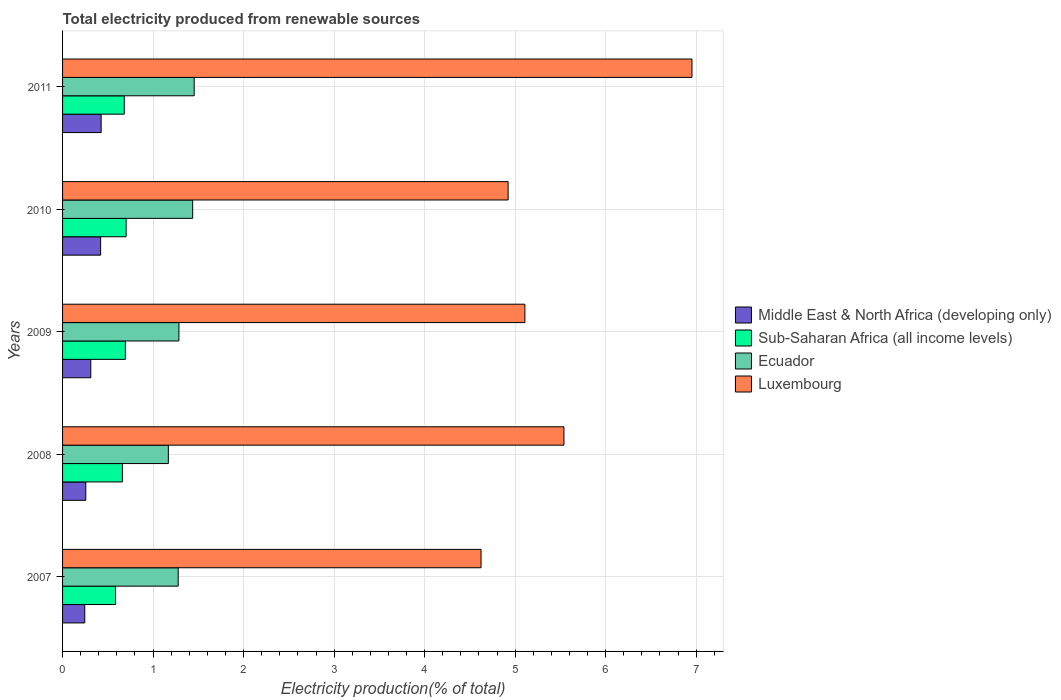How many different coloured bars are there?
Provide a succinct answer. 4. How many groups of bars are there?
Your answer should be compact. 5. Are the number of bars per tick equal to the number of legend labels?
Keep it short and to the point. Yes. How many bars are there on the 3rd tick from the top?
Your answer should be very brief. 4. What is the label of the 4th group of bars from the top?
Ensure brevity in your answer.  2008. What is the total electricity produced in Ecuador in 2009?
Make the answer very short. 1.29. Across all years, what is the maximum total electricity produced in Middle East & North Africa (developing only)?
Offer a terse response. 0.43. Across all years, what is the minimum total electricity produced in Sub-Saharan Africa (all income levels)?
Make the answer very short. 0.58. What is the total total electricity produced in Sub-Saharan Africa (all income levels) in the graph?
Offer a terse response. 3.32. What is the difference between the total electricity produced in Sub-Saharan Africa (all income levels) in 2008 and that in 2011?
Your response must be concise. -0.02. What is the difference between the total electricity produced in Luxembourg in 2011 and the total electricity produced in Sub-Saharan Africa (all income levels) in 2007?
Your answer should be very brief. 6.37. What is the average total electricity produced in Sub-Saharan Africa (all income levels) per year?
Provide a succinct answer. 0.66. In the year 2010, what is the difference between the total electricity produced in Ecuador and total electricity produced in Luxembourg?
Ensure brevity in your answer.  -3.49. In how many years, is the total electricity produced in Ecuador greater than 1.8 %?
Your response must be concise. 0. What is the ratio of the total electricity produced in Sub-Saharan Africa (all income levels) in 2009 to that in 2011?
Provide a succinct answer. 1.02. Is the total electricity produced in Luxembourg in 2010 less than that in 2011?
Keep it short and to the point. Yes. What is the difference between the highest and the second highest total electricity produced in Sub-Saharan Africa (all income levels)?
Provide a short and direct response. 0.01. What is the difference between the highest and the lowest total electricity produced in Sub-Saharan Africa (all income levels)?
Give a very brief answer. 0.12. In how many years, is the total electricity produced in Ecuador greater than the average total electricity produced in Ecuador taken over all years?
Ensure brevity in your answer.  2. Is the sum of the total electricity produced in Sub-Saharan Africa (all income levels) in 2008 and 2011 greater than the maximum total electricity produced in Ecuador across all years?
Your answer should be compact. No. What does the 1st bar from the top in 2010 represents?
Provide a short and direct response. Luxembourg. What does the 3rd bar from the bottom in 2010 represents?
Keep it short and to the point. Ecuador. How many years are there in the graph?
Keep it short and to the point. 5. Does the graph contain any zero values?
Give a very brief answer. No. Does the graph contain grids?
Give a very brief answer. Yes. Where does the legend appear in the graph?
Provide a short and direct response. Center right. How many legend labels are there?
Your response must be concise. 4. What is the title of the graph?
Your answer should be compact. Total electricity produced from renewable sources. What is the label or title of the X-axis?
Your answer should be compact. Electricity production(% of total). What is the Electricity production(% of total) in Middle East & North Africa (developing only) in 2007?
Offer a terse response. 0.25. What is the Electricity production(% of total) in Sub-Saharan Africa (all income levels) in 2007?
Make the answer very short. 0.58. What is the Electricity production(% of total) of Ecuador in 2007?
Your answer should be compact. 1.28. What is the Electricity production(% of total) of Luxembourg in 2007?
Provide a short and direct response. 4.62. What is the Electricity production(% of total) in Middle East & North Africa (developing only) in 2008?
Your answer should be compact. 0.26. What is the Electricity production(% of total) in Sub-Saharan Africa (all income levels) in 2008?
Make the answer very short. 0.66. What is the Electricity production(% of total) in Ecuador in 2008?
Ensure brevity in your answer.  1.17. What is the Electricity production(% of total) in Luxembourg in 2008?
Your answer should be very brief. 5.54. What is the Electricity production(% of total) in Middle East & North Africa (developing only) in 2009?
Ensure brevity in your answer.  0.31. What is the Electricity production(% of total) of Sub-Saharan Africa (all income levels) in 2009?
Make the answer very short. 0.69. What is the Electricity production(% of total) of Ecuador in 2009?
Your answer should be very brief. 1.29. What is the Electricity production(% of total) in Luxembourg in 2009?
Give a very brief answer. 5.11. What is the Electricity production(% of total) of Middle East & North Africa (developing only) in 2010?
Provide a succinct answer. 0.42. What is the Electricity production(% of total) of Sub-Saharan Africa (all income levels) in 2010?
Give a very brief answer. 0.7. What is the Electricity production(% of total) in Ecuador in 2010?
Give a very brief answer. 1.44. What is the Electricity production(% of total) in Luxembourg in 2010?
Provide a succinct answer. 4.92. What is the Electricity production(% of total) of Middle East & North Africa (developing only) in 2011?
Offer a terse response. 0.43. What is the Electricity production(% of total) of Sub-Saharan Africa (all income levels) in 2011?
Give a very brief answer. 0.68. What is the Electricity production(% of total) of Ecuador in 2011?
Make the answer very short. 1.45. What is the Electricity production(% of total) of Luxembourg in 2011?
Your response must be concise. 6.95. Across all years, what is the maximum Electricity production(% of total) of Middle East & North Africa (developing only)?
Your answer should be compact. 0.43. Across all years, what is the maximum Electricity production(% of total) of Sub-Saharan Africa (all income levels)?
Give a very brief answer. 0.7. Across all years, what is the maximum Electricity production(% of total) in Ecuador?
Your answer should be compact. 1.45. Across all years, what is the maximum Electricity production(% of total) of Luxembourg?
Ensure brevity in your answer.  6.95. Across all years, what is the minimum Electricity production(% of total) in Middle East & North Africa (developing only)?
Provide a succinct answer. 0.25. Across all years, what is the minimum Electricity production(% of total) in Sub-Saharan Africa (all income levels)?
Provide a succinct answer. 0.58. Across all years, what is the minimum Electricity production(% of total) in Ecuador?
Your response must be concise. 1.17. Across all years, what is the minimum Electricity production(% of total) of Luxembourg?
Give a very brief answer. 4.62. What is the total Electricity production(% of total) of Middle East & North Africa (developing only) in the graph?
Offer a terse response. 1.66. What is the total Electricity production(% of total) of Sub-Saharan Africa (all income levels) in the graph?
Provide a succinct answer. 3.32. What is the total Electricity production(% of total) of Ecuador in the graph?
Make the answer very short. 6.62. What is the total Electricity production(% of total) of Luxembourg in the graph?
Your answer should be very brief. 27.15. What is the difference between the Electricity production(% of total) in Middle East & North Africa (developing only) in 2007 and that in 2008?
Your answer should be compact. -0.01. What is the difference between the Electricity production(% of total) in Sub-Saharan Africa (all income levels) in 2007 and that in 2008?
Give a very brief answer. -0.08. What is the difference between the Electricity production(% of total) of Ecuador in 2007 and that in 2008?
Your response must be concise. 0.11. What is the difference between the Electricity production(% of total) in Luxembourg in 2007 and that in 2008?
Provide a short and direct response. -0.92. What is the difference between the Electricity production(% of total) in Middle East & North Africa (developing only) in 2007 and that in 2009?
Make the answer very short. -0.07. What is the difference between the Electricity production(% of total) in Sub-Saharan Africa (all income levels) in 2007 and that in 2009?
Offer a very short reply. -0.11. What is the difference between the Electricity production(% of total) in Ecuador in 2007 and that in 2009?
Ensure brevity in your answer.  -0.01. What is the difference between the Electricity production(% of total) in Luxembourg in 2007 and that in 2009?
Give a very brief answer. -0.48. What is the difference between the Electricity production(% of total) in Middle East & North Africa (developing only) in 2007 and that in 2010?
Provide a short and direct response. -0.18. What is the difference between the Electricity production(% of total) of Sub-Saharan Africa (all income levels) in 2007 and that in 2010?
Provide a succinct answer. -0.12. What is the difference between the Electricity production(% of total) of Ecuador in 2007 and that in 2010?
Provide a succinct answer. -0.16. What is the difference between the Electricity production(% of total) in Luxembourg in 2007 and that in 2010?
Your answer should be very brief. -0.3. What is the difference between the Electricity production(% of total) of Middle East & North Africa (developing only) in 2007 and that in 2011?
Give a very brief answer. -0.18. What is the difference between the Electricity production(% of total) in Sub-Saharan Africa (all income levels) in 2007 and that in 2011?
Your answer should be compact. -0.1. What is the difference between the Electricity production(% of total) of Ecuador in 2007 and that in 2011?
Your response must be concise. -0.18. What is the difference between the Electricity production(% of total) in Luxembourg in 2007 and that in 2011?
Your response must be concise. -2.33. What is the difference between the Electricity production(% of total) in Middle East & North Africa (developing only) in 2008 and that in 2009?
Give a very brief answer. -0.06. What is the difference between the Electricity production(% of total) in Sub-Saharan Africa (all income levels) in 2008 and that in 2009?
Keep it short and to the point. -0.03. What is the difference between the Electricity production(% of total) in Ecuador in 2008 and that in 2009?
Your response must be concise. -0.12. What is the difference between the Electricity production(% of total) of Luxembourg in 2008 and that in 2009?
Provide a succinct answer. 0.43. What is the difference between the Electricity production(% of total) in Middle East & North Africa (developing only) in 2008 and that in 2010?
Keep it short and to the point. -0.16. What is the difference between the Electricity production(% of total) of Sub-Saharan Africa (all income levels) in 2008 and that in 2010?
Offer a terse response. -0.04. What is the difference between the Electricity production(% of total) of Ecuador in 2008 and that in 2010?
Provide a succinct answer. -0.27. What is the difference between the Electricity production(% of total) in Luxembourg in 2008 and that in 2010?
Offer a terse response. 0.62. What is the difference between the Electricity production(% of total) of Middle East & North Africa (developing only) in 2008 and that in 2011?
Your answer should be compact. -0.17. What is the difference between the Electricity production(% of total) of Sub-Saharan Africa (all income levels) in 2008 and that in 2011?
Make the answer very short. -0.02. What is the difference between the Electricity production(% of total) of Ecuador in 2008 and that in 2011?
Keep it short and to the point. -0.29. What is the difference between the Electricity production(% of total) of Luxembourg in 2008 and that in 2011?
Your response must be concise. -1.41. What is the difference between the Electricity production(% of total) of Middle East & North Africa (developing only) in 2009 and that in 2010?
Keep it short and to the point. -0.11. What is the difference between the Electricity production(% of total) in Sub-Saharan Africa (all income levels) in 2009 and that in 2010?
Keep it short and to the point. -0.01. What is the difference between the Electricity production(% of total) of Ecuador in 2009 and that in 2010?
Provide a succinct answer. -0.15. What is the difference between the Electricity production(% of total) of Luxembourg in 2009 and that in 2010?
Ensure brevity in your answer.  0.19. What is the difference between the Electricity production(% of total) of Middle East & North Africa (developing only) in 2009 and that in 2011?
Offer a terse response. -0.11. What is the difference between the Electricity production(% of total) in Sub-Saharan Africa (all income levels) in 2009 and that in 2011?
Your answer should be compact. 0.01. What is the difference between the Electricity production(% of total) in Ecuador in 2009 and that in 2011?
Provide a succinct answer. -0.17. What is the difference between the Electricity production(% of total) of Luxembourg in 2009 and that in 2011?
Provide a succinct answer. -1.85. What is the difference between the Electricity production(% of total) of Middle East & North Africa (developing only) in 2010 and that in 2011?
Your response must be concise. -0.01. What is the difference between the Electricity production(% of total) in Sub-Saharan Africa (all income levels) in 2010 and that in 2011?
Offer a very short reply. 0.02. What is the difference between the Electricity production(% of total) in Ecuador in 2010 and that in 2011?
Keep it short and to the point. -0.02. What is the difference between the Electricity production(% of total) of Luxembourg in 2010 and that in 2011?
Keep it short and to the point. -2.03. What is the difference between the Electricity production(% of total) of Middle East & North Africa (developing only) in 2007 and the Electricity production(% of total) of Sub-Saharan Africa (all income levels) in 2008?
Your answer should be very brief. -0.42. What is the difference between the Electricity production(% of total) in Middle East & North Africa (developing only) in 2007 and the Electricity production(% of total) in Ecuador in 2008?
Make the answer very short. -0.92. What is the difference between the Electricity production(% of total) of Middle East & North Africa (developing only) in 2007 and the Electricity production(% of total) of Luxembourg in 2008?
Offer a very short reply. -5.29. What is the difference between the Electricity production(% of total) in Sub-Saharan Africa (all income levels) in 2007 and the Electricity production(% of total) in Ecuador in 2008?
Give a very brief answer. -0.58. What is the difference between the Electricity production(% of total) of Sub-Saharan Africa (all income levels) in 2007 and the Electricity production(% of total) of Luxembourg in 2008?
Give a very brief answer. -4.95. What is the difference between the Electricity production(% of total) in Ecuador in 2007 and the Electricity production(% of total) in Luxembourg in 2008?
Your answer should be very brief. -4.26. What is the difference between the Electricity production(% of total) in Middle East & North Africa (developing only) in 2007 and the Electricity production(% of total) in Sub-Saharan Africa (all income levels) in 2009?
Give a very brief answer. -0.45. What is the difference between the Electricity production(% of total) in Middle East & North Africa (developing only) in 2007 and the Electricity production(% of total) in Ecuador in 2009?
Provide a short and direct response. -1.04. What is the difference between the Electricity production(% of total) of Middle East & North Africa (developing only) in 2007 and the Electricity production(% of total) of Luxembourg in 2009?
Your answer should be compact. -4.86. What is the difference between the Electricity production(% of total) of Sub-Saharan Africa (all income levels) in 2007 and the Electricity production(% of total) of Ecuador in 2009?
Your answer should be compact. -0.7. What is the difference between the Electricity production(% of total) in Sub-Saharan Africa (all income levels) in 2007 and the Electricity production(% of total) in Luxembourg in 2009?
Your answer should be very brief. -4.52. What is the difference between the Electricity production(% of total) in Ecuador in 2007 and the Electricity production(% of total) in Luxembourg in 2009?
Your response must be concise. -3.83. What is the difference between the Electricity production(% of total) of Middle East & North Africa (developing only) in 2007 and the Electricity production(% of total) of Sub-Saharan Africa (all income levels) in 2010?
Ensure brevity in your answer.  -0.46. What is the difference between the Electricity production(% of total) of Middle East & North Africa (developing only) in 2007 and the Electricity production(% of total) of Ecuador in 2010?
Ensure brevity in your answer.  -1.19. What is the difference between the Electricity production(% of total) of Middle East & North Africa (developing only) in 2007 and the Electricity production(% of total) of Luxembourg in 2010?
Keep it short and to the point. -4.68. What is the difference between the Electricity production(% of total) of Sub-Saharan Africa (all income levels) in 2007 and the Electricity production(% of total) of Ecuador in 2010?
Offer a terse response. -0.85. What is the difference between the Electricity production(% of total) in Sub-Saharan Africa (all income levels) in 2007 and the Electricity production(% of total) in Luxembourg in 2010?
Keep it short and to the point. -4.34. What is the difference between the Electricity production(% of total) in Ecuador in 2007 and the Electricity production(% of total) in Luxembourg in 2010?
Keep it short and to the point. -3.65. What is the difference between the Electricity production(% of total) in Middle East & North Africa (developing only) in 2007 and the Electricity production(% of total) in Sub-Saharan Africa (all income levels) in 2011?
Your answer should be compact. -0.44. What is the difference between the Electricity production(% of total) in Middle East & North Africa (developing only) in 2007 and the Electricity production(% of total) in Ecuador in 2011?
Provide a short and direct response. -1.21. What is the difference between the Electricity production(% of total) in Middle East & North Africa (developing only) in 2007 and the Electricity production(% of total) in Luxembourg in 2011?
Keep it short and to the point. -6.71. What is the difference between the Electricity production(% of total) of Sub-Saharan Africa (all income levels) in 2007 and the Electricity production(% of total) of Ecuador in 2011?
Keep it short and to the point. -0.87. What is the difference between the Electricity production(% of total) in Sub-Saharan Africa (all income levels) in 2007 and the Electricity production(% of total) in Luxembourg in 2011?
Your response must be concise. -6.37. What is the difference between the Electricity production(% of total) of Ecuador in 2007 and the Electricity production(% of total) of Luxembourg in 2011?
Make the answer very short. -5.68. What is the difference between the Electricity production(% of total) of Middle East & North Africa (developing only) in 2008 and the Electricity production(% of total) of Sub-Saharan Africa (all income levels) in 2009?
Your answer should be compact. -0.44. What is the difference between the Electricity production(% of total) of Middle East & North Africa (developing only) in 2008 and the Electricity production(% of total) of Ecuador in 2009?
Ensure brevity in your answer.  -1.03. What is the difference between the Electricity production(% of total) of Middle East & North Africa (developing only) in 2008 and the Electricity production(% of total) of Luxembourg in 2009?
Keep it short and to the point. -4.85. What is the difference between the Electricity production(% of total) of Sub-Saharan Africa (all income levels) in 2008 and the Electricity production(% of total) of Ecuador in 2009?
Keep it short and to the point. -0.62. What is the difference between the Electricity production(% of total) of Sub-Saharan Africa (all income levels) in 2008 and the Electricity production(% of total) of Luxembourg in 2009?
Offer a terse response. -4.45. What is the difference between the Electricity production(% of total) in Ecuador in 2008 and the Electricity production(% of total) in Luxembourg in 2009?
Your response must be concise. -3.94. What is the difference between the Electricity production(% of total) of Middle East & North Africa (developing only) in 2008 and the Electricity production(% of total) of Sub-Saharan Africa (all income levels) in 2010?
Your answer should be very brief. -0.45. What is the difference between the Electricity production(% of total) in Middle East & North Africa (developing only) in 2008 and the Electricity production(% of total) in Ecuador in 2010?
Provide a succinct answer. -1.18. What is the difference between the Electricity production(% of total) of Middle East & North Africa (developing only) in 2008 and the Electricity production(% of total) of Luxembourg in 2010?
Keep it short and to the point. -4.67. What is the difference between the Electricity production(% of total) of Sub-Saharan Africa (all income levels) in 2008 and the Electricity production(% of total) of Ecuador in 2010?
Provide a short and direct response. -0.78. What is the difference between the Electricity production(% of total) in Sub-Saharan Africa (all income levels) in 2008 and the Electricity production(% of total) in Luxembourg in 2010?
Give a very brief answer. -4.26. What is the difference between the Electricity production(% of total) in Ecuador in 2008 and the Electricity production(% of total) in Luxembourg in 2010?
Provide a short and direct response. -3.75. What is the difference between the Electricity production(% of total) of Middle East & North Africa (developing only) in 2008 and the Electricity production(% of total) of Sub-Saharan Africa (all income levels) in 2011?
Ensure brevity in your answer.  -0.43. What is the difference between the Electricity production(% of total) in Middle East & North Africa (developing only) in 2008 and the Electricity production(% of total) in Ecuador in 2011?
Your answer should be very brief. -1.2. What is the difference between the Electricity production(% of total) of Middle East & North Africa (developing only) in 2008 and the Electricity production(% of total) of Luxembourg in 2011?
Your answer should be compact. -6.7. What is the difference between the Electricity production(% of total) in Sub-Saharan Africa (all income levels) in 2008 and the Electricity production(% of total) in Ecuador in 2011?
Keep it short and to the point. -0.79. What is the difference between the Electricity production(% of total) in Sub-Saharan Africa (all income levels) in 2008 and the Electricity production(% of total) in Luxembourg in 2011?
Ensure brevity in your answer.  -6.29. What is the difference between the Electricity production(% of total) of Ecuador in 2008 and the Electricity production(% of total) of Luxembourg in 2011?
Your response must be concise. -5.79. What is the difference between the Electricity production(% of total) of Middle East & North Africa (developing only) in 2009 and the Electricity production(% of total) of Sub-Saharan Africa (all income levels) in 2010?
Your response must be concise. -0.39. What is the difference between the Electricity production(% of total) of Middle East & North Africa (developing only) in 2009 and the Electricity production(% of total) of Ecuador in 2010?
Your answer should be compact. -1.13. What is the difference between the Electricity production(% of total) in Middle East & North Africa (developing only) in 2009 and the Electricity production(% of total) in Luxembourg in 2010?
Your answer should be compact. -4.61. What is the difference between the Electricity production(% of total) of Sub-Saharan Africa (all income levels) in 2009 and the Electricity production(% of total) of Ecuador in 2010?
Ensure brevity in your answer.  -0.74. What is the difference between the Electricity production(% of total) in Sub-Saharan Africa (all income levels) in 2009 and the Electricity production(% of total) in Luxembourg in 2010?
Provide a succinct answer. -4.23. What is the difference between the Electricity production(% of total) of Ecuador in 2009 and the Electricity production(% of total) of Luxembourg in 2010?
Your answer should be compact. -3.64. What is the difference between the Electricity production(% of total) of Middle East & North Africa (developing only) in 2009 and the Electricity production(% of total) of Sub-Saharan Africa (all income levels) in 2011?
Your answer should be very brief. -0.37. What is the difference between the Electricity production(% of total) of Middle East & North Africa (developing only) in 2009 and the Electricity production(% of total) of Ecuador in 2011?
Offer a very short reply. -1.14. What is the difference between the Electricity production(% of total) of Middle East & North Africa (developing only) in 2009 and the Electricity production(% of total) of Luxembourg in 2011?
Offer a terse response. -6.64. What is the difference between the Electricity production(% of total) of Sub-Saharan Africa (all income levels) in 2009 and the Electricity production(% of total) of Ecuador in 2011?
Keep it short and to the point. -0.76. What is the difference between the Electricity production(% of total) of Sub-Saharan Africa (all income levels) in 2009 and the Electricity production(% of total) of Luxembourg in 2011?
Provide a short and direct response. -6.26. What is the difference between the Electricity production(% of total) in Ecuador in 2009 and the Electricity production(% of total) in Luxembourg in 2011?
Make the answer very short. -5.67. What is the difference between the Electricity production(% of total) of Middle East & North Africa (developing only) in 2010 and the Electricity production(% of total) of Sub-Saharan Africa (all income levels) in 2011?
Give a very brief answer. -0.26. What is the difference between the Electricity production(% of total) in Middle East & North Africa (developing only) in 2010 and the Electricity production(% of total) in Ecuador in 2011?
Offer a very short reply. -1.03. What is the difference between the Electricity production(% of total) in Middle East & North Africa (developing only) in 2010 and the Electricity production(% of total) in Luxembourg in 2011?
Offer a very short reply. -6.53. What is the difference between the Electricity production(% of total) of Sub-Saharan Africa (all income levels) in 2010 and the Electricity production(% of total) of Ecuador in 2011?
Your answer should be compact. -0.75. What is the difference between the Electricity production(% of total) in Sub-Saharan Africa (all income levels) in 2010 and the Electricity production(% of total) in Luxembourg in 2011?
Provide a succinct answer. -6.25. What is the difference between the Electricity production(% of total) of Ecuador in 2010 and the Electricity production(% of total) of Luxembourg in 2011?
Offer a very short reply. -5.52. What is the average Electricity production(% of total) of Middle East & North Africa (developing only) per year?
Your response must be concise. 0.33. What is the average Electricity production(% of total) of Sub-Saharan Africa (all income levels) per year?
Ensure brevity in your answer.  0.66. What is the average Electricity production(% of total) in Ecuador per year?
Offer a terse response. 1.32. What is the average Electricity production(% of total) of Luxembourg per year?
Ensure brevity in your answer.  5.43. In the year 2007, what is the difference between the Electricity production(% of total) of Middle East & North Africa (developing only) and Electricity production(% of total) of Sub-Saharan Africa (all income levels)?
Offer a terse response. -0.34. In the year 2007, what is the difference between the Electricity production(% of total) of Middle East & North Africa (developing only) and Electricity production(% of total) of Ecuador?
Your answer should be very brief. -1.03. In the year 2007, what is the difference between the Electricity production(% of total) in Middle East & North Africa (developing only) and Electricity production(% of total) in Luxembourg?
Provide a short and direct response. -4.38. In the year 2007, what is the difference between the Electricity production(% of total) of Sub-Saharan Africa (all income levels) and Electricity production(% of total) of Ecuador?
Your response must be concise. -0.69. In the year 2007, what is the difference between the Electricity production(% of total) of Sub-Saharan Africa (all income levels) and Electricity production(% of total) of Luxembourg?
Keep it short and to the point. -4.04. In the year 2007, what is the difference between the Electricity production(% of total) of Ecuador and Electricity production(% of total) of Luxembourg?
Offer a very short reply. -3.35. In the year 2008, what is the difference between the Electricity production(% of total) of Middle East & North Africa (developing only) and Electricity production(% of total) of Sub-Saharan Africa (all income levels)?
Your response must be concise. -0.4. In the year 2008, what is the difference between the Electricity production(% of total) in Middle East & North Africa (developing only) and Electricity production(% of total) in Ecuador?
Make the answer very short. -0.91. In the year 2008, what is the difference between the Electricity production(% of total) in Middle East & North Africa (developing only) and Electricity production(% of total) in Luxembourg?
Give a very brief answer. -5.28. In the year 2008, what is the difference between the Electricity production(% of total) of Sub-Saharan Africa (all income levels) and Electricity production(% of total) of Ecuador?
Provide a short and direct response. -0.51. In the year 2008, what is the difference between the Electricity production(% of total) of Sub-Saharan Africa (all income levels) and Electricity production(% of total) of Luxembourg?
Give a very brief answer. -4.88. In the year 2008, what is the difference between the Electricity production(% of total) of Ecuador and Electricity production(% of total) of Luxembourg?
Your answer should be compact. -4.37. In the year 2009, what is the difference between the Electricity production(% of total) of Middle East & North Africa (developing only) and Electricity production(% of total) of Sub-Saharan Africa (all income levels)?
Offer a terse response. -0.38. In the year 2009, what is the difference between the Electricity production(% of total) in Middle East & North Africa (developing only) and Electricity production(% of total) in Ecuador?
Your answer should be compact. -0.97. In the year 2009, what is the difference between the Electricity production(% of total) of Middle East & North Africa (developing only) and Electricity production(% of total) of Luxembourg?
Your answer should be compact. -4.8. In the year 2009, what is the difference between the Electricity production(% of total) in Sub-Saharan Africa (all income levels) and Electricity production(% of total) in Ecuador?
Provide a succinct answer. -0.59. In the year 2009, what is the difference between the Electricity production(% of total) in Sub-Saharan Africa (all income levels) and Electricity production(% of total) in Luxembourg?
Keep it short and to the point. -4.41. In the year 2009, what is the difference between the Electricity production(% of total) in Ecuador and Electricity production(% of total) in Luxembourg?
Your response must be concise. -3.82. In the year 2010, what is the difference between the Electricity production(% of total) of Middle East & North Africa (developing only) and Electricity production(% of total) of Sub-Saharan Africa (all income levels)?
Your answer should be very brief. -0.28. In the year 2010, what is the difference between the Electricity production(% of total) of Middle East & North Africa (developing only) and Electricity production(% of total) of Ecuador?
Your answer should be very brief. -1.02. In the year 2010, what is the difference between the Electricity production(% of total) of Middle East & North Africa (developing only) and Electricity production(% of total) of Luxembourg?
Provide a succinct answer. -4.5. In the year 2010, what is the difference between the Electricity production(% of total) in Sub-Saharan Africa (all income levels) and Electricity production(% of total) in Ecuador?
Your response must be concise. -0.74. In the year 2010, what is the difference between the Electricity production(% of total) in Sub-Saharan Africa (all income levels) and Electricity production(% of total) in Luxembourg?
Give a very brief answer. -4.22. In the year 2010, what is the difference between the Electricity production(% of total) in Ecuador and Electricity production(% of total) in Luxembourg?
Your answer should be very brief. -3.49. In the year 2011, what is the difference between the Electricity production(% of total) of Middle East & North Africa (developing only) and Electricity production(% of total) of Sub-Saharan Africa (all income levels)?
Offer a terse response. -0.26. In the year 2011, what is the difference between the Electricity production(% of total) of Middle East & North Africa (developing only) and Electricity production(% of total) of Ecuador?
Ensure brevity in your answer.  -1.03. In the year 2011, what is the difference between the Electricity production(% of total) of Middle East & North Africa (developing only) and Electricity production(% of total) of Luxembourg?
Your response must be concise. -6.53. In the year 2011, what is the difference between the Electricity production(% of total) of Sub-Saharan Africa (all income levels) and Electricity production(% of total) of Ecuador?
Your answer should be compact. -0.77. In the year 2011, what is the difference between the Electricity production(% of total) of Sub-Saharan Africa (all income levels) and Electricity production(% of total) of Luxembourg?
Your answer should be very brief. -6.27. In the year 2011, what is the difference between the Electricity production(% of total) in Ecuador and Electricity production(% of total) in Luxembourg?
Your answer should be very brief. -5.5. What is the ratio of the Electricity production(% of total) in Middle East & North Africa (developing only) in 2007 to that in 2008?
Offer a very short reply. 0.96. What is the ratio of the Electricity production(% of total) of Sub-Saharan Africa (all income levels) in 2007 to that in 2008?
Make the answer very short. 0.88. What is the ratio of the Electricity production(% of total) of Ecuador in 2007 to that in 2008?
Your answer should be very brief. 1.09. What is the ratio of the Electricity production(% of total) of Luxembourg in 2007 to that in 2008?
Offer a terse response. 0.83. What is the ratio of the Electricity production(% of total) in Middle East & North Africa (developing only) in 2007 to that in 2009?
Your answer should be compact. 0.79. What is the ratio of the Electricity production(% of total) of Sub-Saharan Africa (all income levels) in 2007 to that in 2009?
Make the answer very short. 0.84. What is the ratio of the Electricity production(% of total) in Ecuador in 2007 to that in 2009?
Ensure brevity in your answer.  0.99. What is the ratio of the Electricity production(% of total) in Luxembourg in 2007 to that in 2009?
Ensure brevity in your answer.  0.91. What is the ratio of the Electricity production(% of total) in Middle East & North Africa (developing only) in 2007 to that in 2010?
Your response must be concise. 0.58. What is the ratio of the Electricity production(% of total) in Sub-Saharan Africa (all income levels) in 2007 to that in 2010?
Provide a succinct answer. 0.83. What is the ratio of the Electricity production(% of total) in Ecuador in 2007 to that in 2010?
Give a very brief answer. 0.89. What is the ratio of the Electricity production(% of total) of Luxembourg in 2007 to that in 2010?
Your answer should be compact. 0.94. What is the ratio of the Electricity production(% of total) of Middle East & North Africa (developing only) in 2007 to that in 2011?
Offer a very short reply. 0.58. What is the ratio of the Electricity production(% of total) of Sub-Saharan Africa (all income levels) in 2007 to that in 2011?
Your answer should be compact. 0.86. What is the ratio of the Electricity production(% of total) in Ecuador in 2007 to that in 2011?
Provide a short and direct response. 0.88. What is the ratio of the Electricity production(% of total) in Luxembourg in 2007 to that in 2011?
Offer a very short reply. 0.66. What is the ratio of the Electricity production(% of total) in Middle East & North Africa (developing only) in 2008 to that in 2009?
Ensure brevity in your answer.  0.82. What is the ratio of the Electricity production(% of total) in Sub-Saharan Africa (all income levels) in 2008 to that in 2009?
Keep it short and to the point. 0.95. What is the ratio of the Electricity production(% of total) in Ecuador in 2008 to that in 2009?
Provide a succinct answer. 0.91. What is the ratio of the Electricity production(% of total) in Luxembourg in 2008 to that in 2009?
Give a very brief answer. 1.08. What is the ratio of the Electricity production(% of total) in Middle East & North Africa (developing only) in 2008 to that in 2010?
Give a very brief answer. 0.61. What is the ratio of the Electricity production(% of total) in Sub-Saharan Africa (all income levels) in 2008 to that in 2010?
Offer a terse response. 0.94. What is the ratio of the Electricity production(% of total) of Ecuador in 2008 to that in 2010?
Give a very brief answer. 0.81. What is the ratio of the Electricity production(% of total) of Luxembourg in 2008 to that in 2010?
Offer a terse response. 1.13. What is the ratio of the Electricity production(% of total) of Middle East & North Africa (developing only) in 2008 to that in 2011?
Provide a succinct answer. 0.6. What is the ratio of the Electricity production(% of total) in Sub-Saharan Africa (all income levels) in 2008 to that in 2011?
Offer a terse response. 0.97. What is the ratio of the Electricity production(% of total) of Ecuador in 2008 to that in 2011?
Offer a terse response. 0.8. What is the ratio of the Electricity production(% of total) of Luxembourg in 2008 to that in 2011?
Your answer should be very brief. 0.8. What is the ratio of the Electricity production(% of total) of Middle East & North Africa (developing only) in 2009 to that in 2010?
Offer a terse response. 0.74. What is the ratio of the Electricity production(% of total) of Sub-Saharan Africa (all income levels) in 2009 to that in 2010?
Your answer should be very brief. 0.99. What is the ratio of the Electricity production(% of total) in Ecuador in 2009 to that in 2010?
Provide a short and direct response. 0.89. What is the ratio of the Electricity production(% of total) in Luxembourg in 2009 to that in 2010?
Offer a terse response. 1.04. What is the ratio of the Electricity production(% of total) of Middle East & North Africa (developing only) in 2009 to that in 2011?
Offer a very short reply. 0.73. What is the ratio of the Electricity production(% of total) in Sub-Saharan Africa (all income levels) in 2009 to that in 2011?
Your answer should be very brief. 1.02. What is the ratio of the Electricity production(% of total) in Ecuador in 2009 to that in 2011?
Offer a very short reply. 0.88. What is the ratio of the Electricity production(% of total) of Luxembourg in 2009 to that in 2011?
Ensure brevity in your answer.  0.73. What is the ratio of the Electricity production(% of total) in Middle East & North Africa (developing only) in 2010 to that in 2011?
Offer a terse response. 0.99. What is the ratio of the Electricity production(% of total) in Sub-Saharan Africa (all income levels) in 2010 to that in 2011?
Keep it short and to the point. 1.03. What is the ratio of the Electricity production(% of total) in Ecuador in 2010 to that in 2011?
Your response must be concise. 0.99. What is the ratio of the Electricity production(% of total) of Luxembourg in 2010 to that in 2011?
Ensure brevity in your answer.  0.71. What is the difference between the highest and the second highest Electricity production(% of total) of Middle East & North Africa (developing only)?
Your answer should be very brief. 0.01. What is the difference between the highest and the second highest Electricity production(% of total) of Sub-Saharan Africa (all income levels)?
Your response must be concise. 0.01. What is the difference between the highest and the second highest Electricity production(% of total) of Ecuador?
Offer a very short reply. 0.02. What is the difference between the highest and the second highest Electricity production(% of total) in Luxembourg?
Give a very brief answer. 1.41. What is the difference between the highest and the lowest Electricity production(% of total) of Middle East & North Africa (developing only)?
Provide a short and direct response. 0.18. What is the difference between the highest and the lowest Electricity production(% of total) of Sub-Saharan Africa (all income levels)?
Your response must be concise. 0.12. What is the difference between the highest and the lowest Electricity production(% of total) of Ecuador?
Give a very brief answer. 0.29. What is the difference between the highest and the lowest Electricity production(% of total) of Luxembourg?
Give a very brief answer. 2.33. 